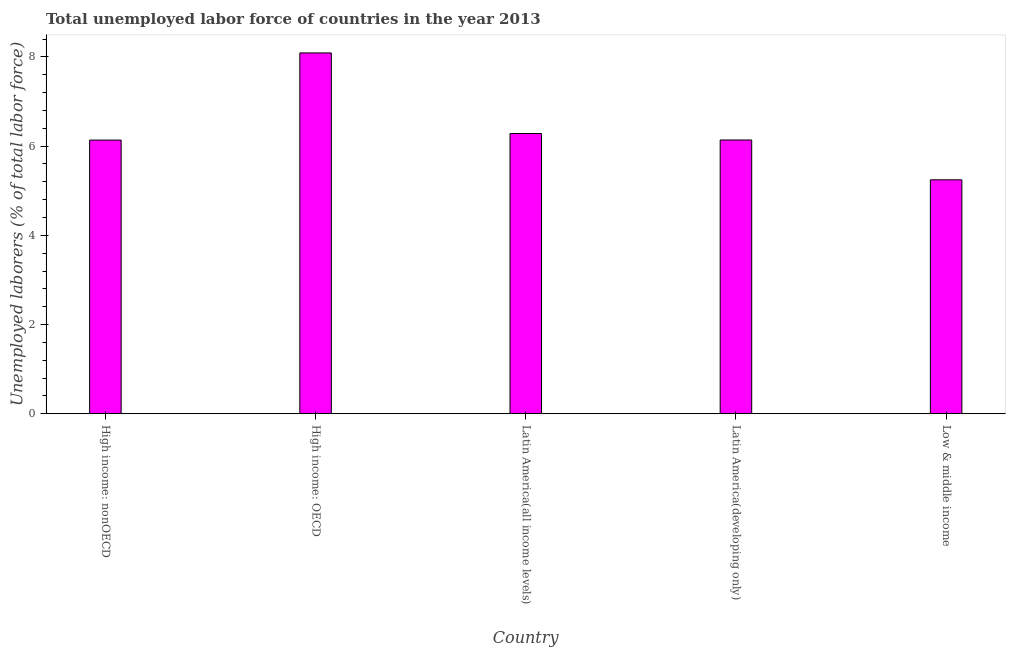Does the graph contain any zero values?
Keep it short and to the point. No. What is the title of the graph?
Keep it short and to the point. Total unemployed labor force of countries in the year 2013. What is the label or title of the X-axis?
Provide a succinct answer. Country. What is the label or title of the Y-axis?
Your answer should be very brief. Unemployed laborers (% of total labor force). What is the total unemployed labour force in Latin America(all income levels)?
Keep it short and to the point. 6.28. Across all countries, what is the maximum total unemployed labour force?
Offer a terse response. 8.09. Across all countries, what is the minimum total unemployed labour force?
Provide a short and direct response. 5.24. In which country was the total unemployed labour force maximum?
Your answer should be compact. High income: OECD. What is the sum of the total unemployed labour force?
Offer a terse response. 31.89. What is the difference between the total unemployed labour force in High income: nonOECD and Latin America(developing only)?
Your answer should be very brief. -0. What is the average total unemployed labour force per country?
Offer a terse response. 6.38. What is the median total unemployed labour force?
Make the answer very short. 6.14. What is the ratio of the total unemployed labour force in High income: nonOECD to that in Low & middle income?
Ensure brevity in your answer.  1.17. Is the total unemployed labour force in High income: nonOECD less than that in Latin America(developing only)?
Offer a terse response. Yes. What is the difference between the highest and the second highest total unemployed labour force?
Give a very brief answer. 1.81. What is the difference between the highest and the lowest total unemployed labour force?
Offer a very short reply. 2.85. In how many countries, is the total unemployed labour force greater than the average total unemployed labour force taken over all countries?
Ensure brevity in your answer.  1. How many bars are there?
Provide a short and direct response. 5. How many countries are there in the graph?
Your answer should be compact. 5. What is the Unemployed laborers (% of total labor force) of High income: nonOECD?
Offer a terse response. 6.14. What is the Unemployed laborers (% of total labor force) in High income: OECD?
Offer a terse response. 8.09. What is the Unemployed laborers (% of total labor force) of Latin America(all income levels)?
Provide a short and direct response. 6.28. What is the Unemployed laborers (% of total labor force) in Latin America(developing only)?
Ensure brevity in your answer.  6.14. What is the Unemployed laborers (% of total labor force) in Low & middle income?
Give a very brief answer. 5.24. What is the difference between the Unemployed laborers (% of total labor force) in High income: nonOECD and High income: OECD?
Your answer should be very brief. -1.95. What is the difference between the Unemployed laborers (% of total labor force) in High income: nonOECD and Latin America(all income levels)?
Keep it short and to the point. -0.15. What is the difference between the Unemployed laborers (% of total labor force) in High income: nonOECD and Latin America(developing only)?
Keep it short and to the point. -0. What is the difference between the Unemployed laborers (% of total labor force) in High income: nonOECD and Low & middle income?
Your answer should be very brief. 0.89. What is the difference between the Unemployed laborers (% of total labor force) in High income: OECD and Latin America(all income levels)?
Make the answer very short. 1.81. What is the difference between the Unemployed laborers (% of total labor force) in High income: OECD and Latin America(developing only)?
Give a very brief answer. 1.95. What is the difference between the Unemployed laborers (% of total labor force) in High income: OECD and Low & middle income?
Ensure brevity in your answer.  2.85. What is the difference between the Unemployed laborers (% of total labor force) in Latin America(all income levels) and Latin America(developing only)?
Your answer should be compact. 0.15. What is the difference between the Unemployed laborers (% of total labor force) in Latin America(all income levels) and Low & middle income?
Provide a short and direct response. 1.04. What is the difference between the Unemployed laborers (% of total labor force) in Latin America(developing only) and Low & middle income?
Keep it short and to the point. 0.89. What is the ratio of the Unemployed laborers (% of total labor force) in High income: nonOECD to that in High income: OECD?
Provide a short and direct response. 0.76. What is the ratio of the Unemployed laborers (% of total labor force) in High income: nonOECD to that in Latin America(all income levels)?
Make the answer very short. 0.98. What is the ratio of the Unemployed laborers (% of total labor force) in High income: nonOECD to that in Low & middle income?
Provide a succinct answer. 1.17. What is the ratio of the Unemployed laborers (% of total labor force) in High income: OECD to that in Latin America(all income levels)?
Offer a very short reply. 1.29. What is the ratio of the Unemployed laborers (% of total labor force) in High income: OECD to that in Latin America(developing only)?
Offer a terse response. 1.32. What is the ratio of the Unemployed laborers (% of total labor force) in High income: OECD to that in Low & middle income?
Your answer should be compact. 1.54. What is the ratio of the Unemployed laborers (% of total labor force) in Latin America(all income levels) to that in Low & middle income?
Provide a succinct answer. 1.2. What is the ratio of the Unemployed laborers (% of total labor force) in Latin America(developing only) to that in Low & middle income?
Offer a terse response. 1.17. 